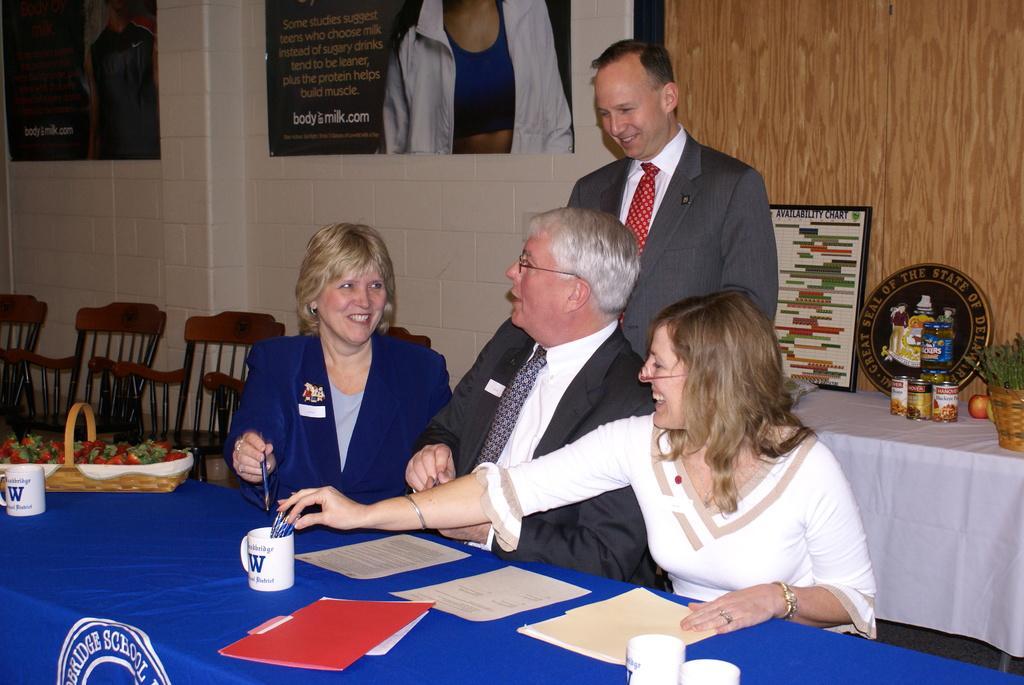In one or two sentences, can you explain what this image depicts? In this image I can see a group of people among them there are sitting in front of a table and one man is standing on the floor. I can also see there are few chairs and tables. On the table I can see there are few few papers, cups and other objects on it. In the background I can see there is a white color wall with two photos. 